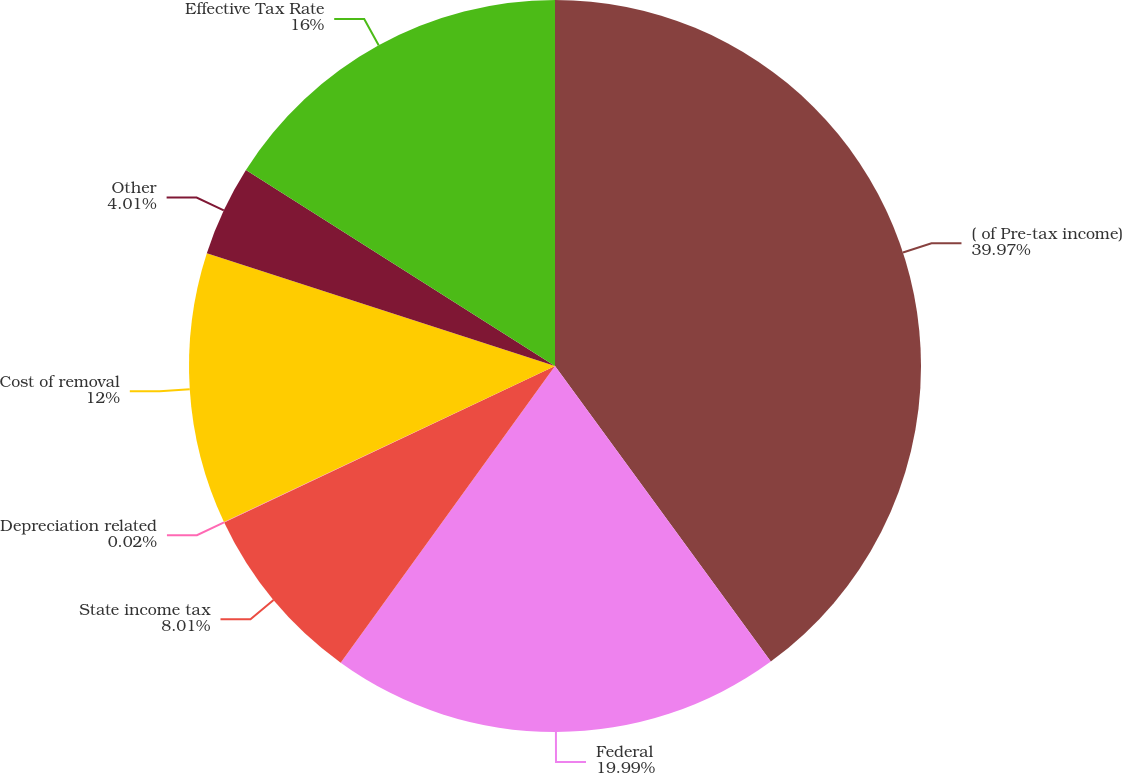Convert chart to OTSL. <chart><loc_0><loc_0><loc_500><loc_500><pie_chart><fcel>( of Pre-tax income)<fcel>Federal<fcel>State income tax<fcel>Depreciation related<fcel>Cost of removal<fcel>Other<fcel>Effective Tax Rate<nl><fcel>39.96%<fcel>19.99%<fcel>8.01%<fcel>0.02%<fcel>12.0%<fcel>4.01%<fcel>16.0%<nl></chart> 